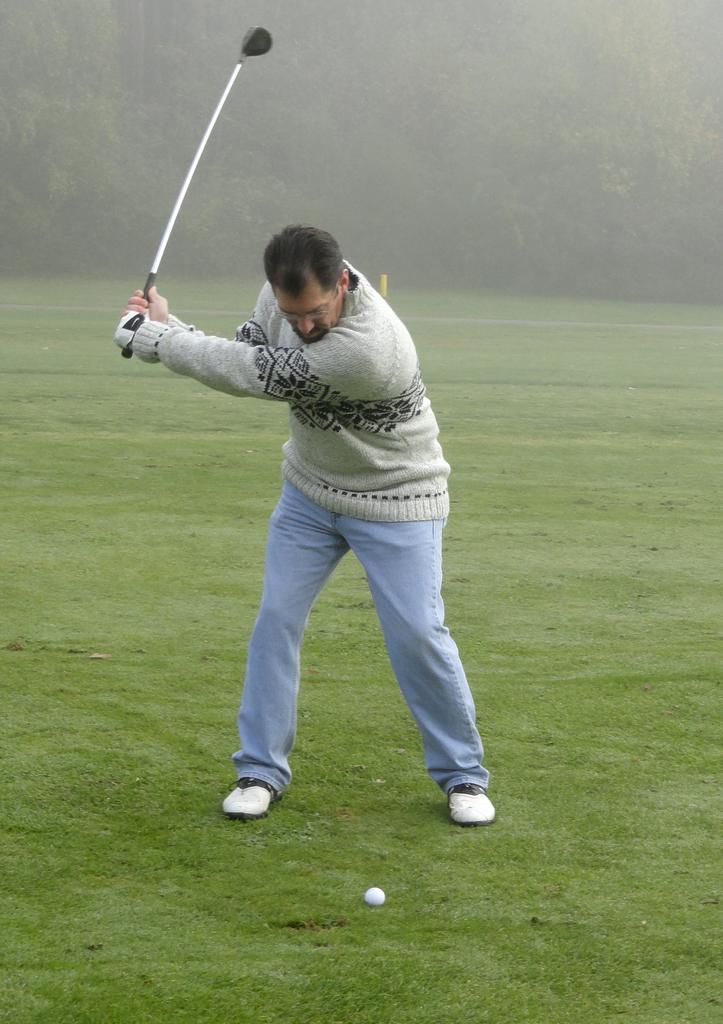Who is the main subject in the image? There is a person in the image. What activity is the person engaged in? The person is playing golf. On what surface is the golf being played? The golf is being played on grass. What type of natural environment is visible in the image? There are trees visible in the image. What type of straw is being used to help the person play golf in the image? There is no straw present in the image, and the person is not receiving any help to play golf. 